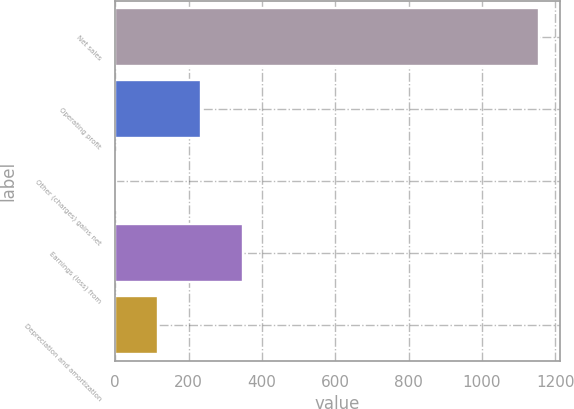<chart> <loc_0><loc_0><loc_500><loc_500><bar_chart><fcel>Net sales<fcel>Operating profit<fcel>Other (charges) gains net<fcel>Earnings (loss) from<fcel>Depreciation and amortization<nl><fcel>1155<fcel>232.6<fcel>2<fcel>347.9<fcel>117.3<nl></chart> 